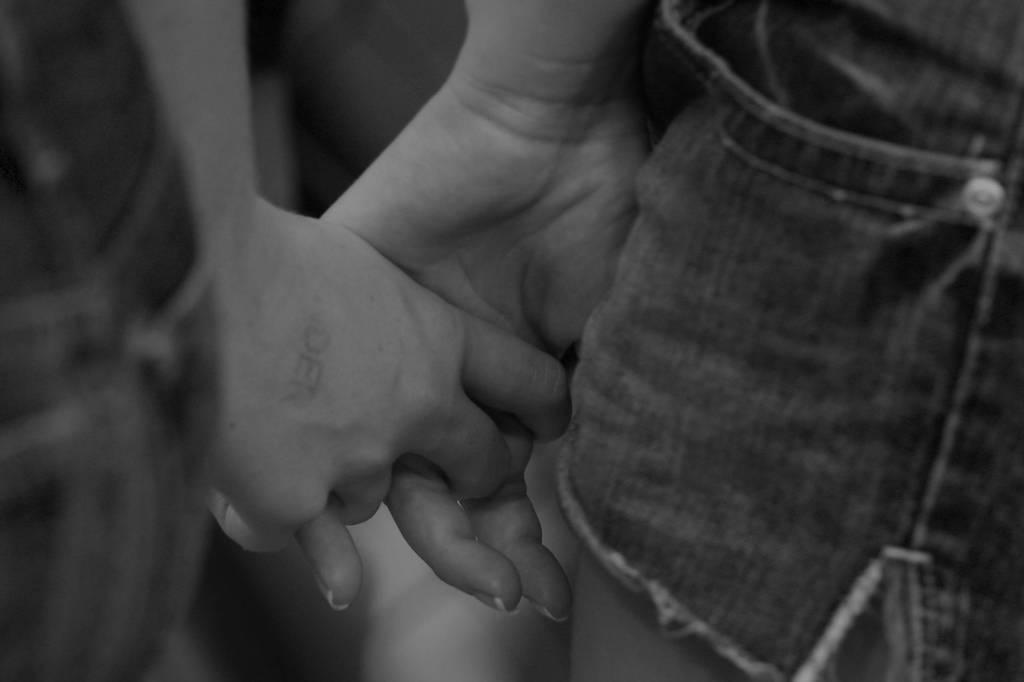How many people are in the image? There are two persons in the image. What are the two persons doing in the image? The two persons are holding hands. What type of clothing are the persons wearing? Both persons are wearing jeans. What is the color scheme of the image? The image is in black and white. Where is the throne located in the image? There is no throne present in the image. What degree do the persons in the image hold? The image does not provide information about the persons' degrees or qualifications. 